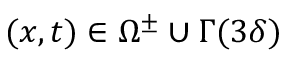Convert formula to latex. <formula><loc_0><loc_0><loc_500><loc_500>( x , t ) \in \Omega ^ { \pm } \cup \Gamma ( 3 \delta )</formula> 